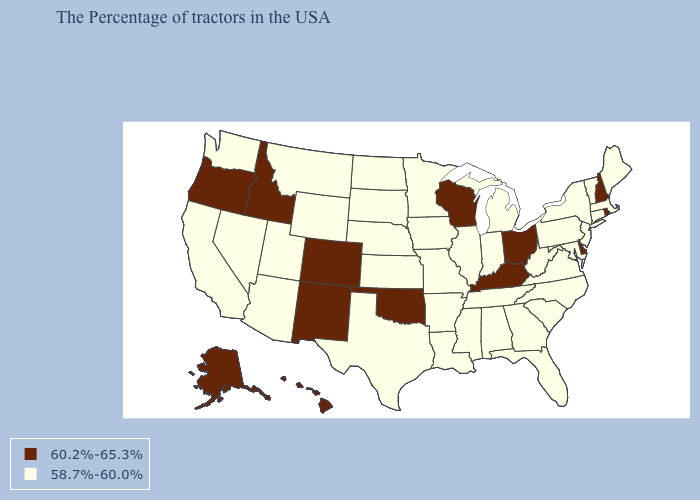Does Alaska have the highest value in the USA?
Concise answer only. Yes. Name the states that have a value in the range 58.7%-60.0%?
Be succinct. Maine, Massachusetts, Vermont, Connecticut, New York, New Jersey, Maryland, Pennsylvania, Virginia, North Carolina, South Carolina, West Virginia, Florida, Georgia, Michigan, Indiana, Alabama, Tennessee, Illinois, Mississippi, Louisiana, Missouri, Arkansas, Minnesota, Iowa, Kansas, Nebraska, Texas, South Dakota, North Dakota, Wyoming, Utah, Montana, Arizona, Nevada, California, Washington. Does the map have missing data?
Write a very short answer. No. Is the legend a continuous bar?
Write a very short answer. No. Which states have the lowest value in the West?
Quick response, please. Wyoming, Utah, Montana, Arizona, Nevada, California, Washington. Which states have the lowest value in the MidWest?
Write a very short answer. Michigan, Indiana, Illinois, Missouri, Minnesota, Iowa, Kansas, Nebraska, South Dakota, North Dakota. Does Wisconsin have the highest value in the MidWest?
Concise answer only. Yes. Which states have the lowest value in the MidWest?
Keep it brief. Michigan, Indiana, Illinois, Missouri, Minnesota, Iowa, Kansas, Nebraska, South Dakota, North Dakota. What is the value of Delaware?
Give a very brief answer. 60.2%-65.3%. Name the states that have a value in the range 58.7%-60.0%?
Answer briefly. Maine, Massachusetts, Vermont, Connecticut, New York, New Jersey, Maryland, Pennsylvania, Virginia, North Carolina, South Carolina, West Virginia, Florida, Georgia, Michigan, Indiana, Alabama, Tennessee, Illinois, Mississippi, Louisiana, Missouri, Arkansas, Minnesota, Iowa, Kansas, Nebraska, Texas, South Dakota, North Dakota, Wyoming, Utah, Montana, Arizona, Nevada, California, Washington. Name the states that have a value in the range 58.7%-60.0%?
Concise answer only. Maine, Massachusetts, Vermont, Connecticut, New York, New Jersey, Maryland, Pennsylvania, Virginia, North Carolina, South Carolina, West Virginia, Florida, Georgia, Michigan, Indiana, Alabama, Tennessee, Illinois, Mississippi, Louisiana, Missouri, Arkansas, Minnesota, Iowa, Kansas, Nebraska, Texas, South Dakota, North Dakota, Wyoming, Utah, Montana, Arizona, Nevada, California, Washington. Does New Hampshire have the highest value in the Northeast?
Concise answer only. Yes. Among the states that border Florida , which have the highest value?
Be succinct. Georgia, Alabama. Does Louisiana have the same value as Wyoming?
Quick response, please. Yes. 